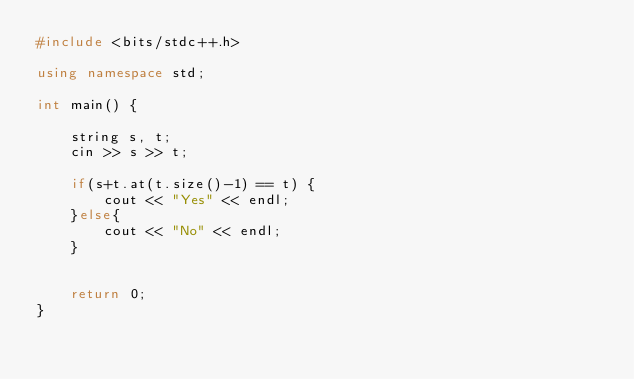<code> <loc_0><loc_0><loc_500><loc_500><_C++_>#include <bits/stdc++.h>

using namespace std;

int main() {

    string s, t;
    cin >> s >> t;

    if(s+t.at(t.size()-1) == t) {
        cout << "Yes" << endl;
    }else{
        cout << "No" << endl;
    }


    return 0;
}</code> 